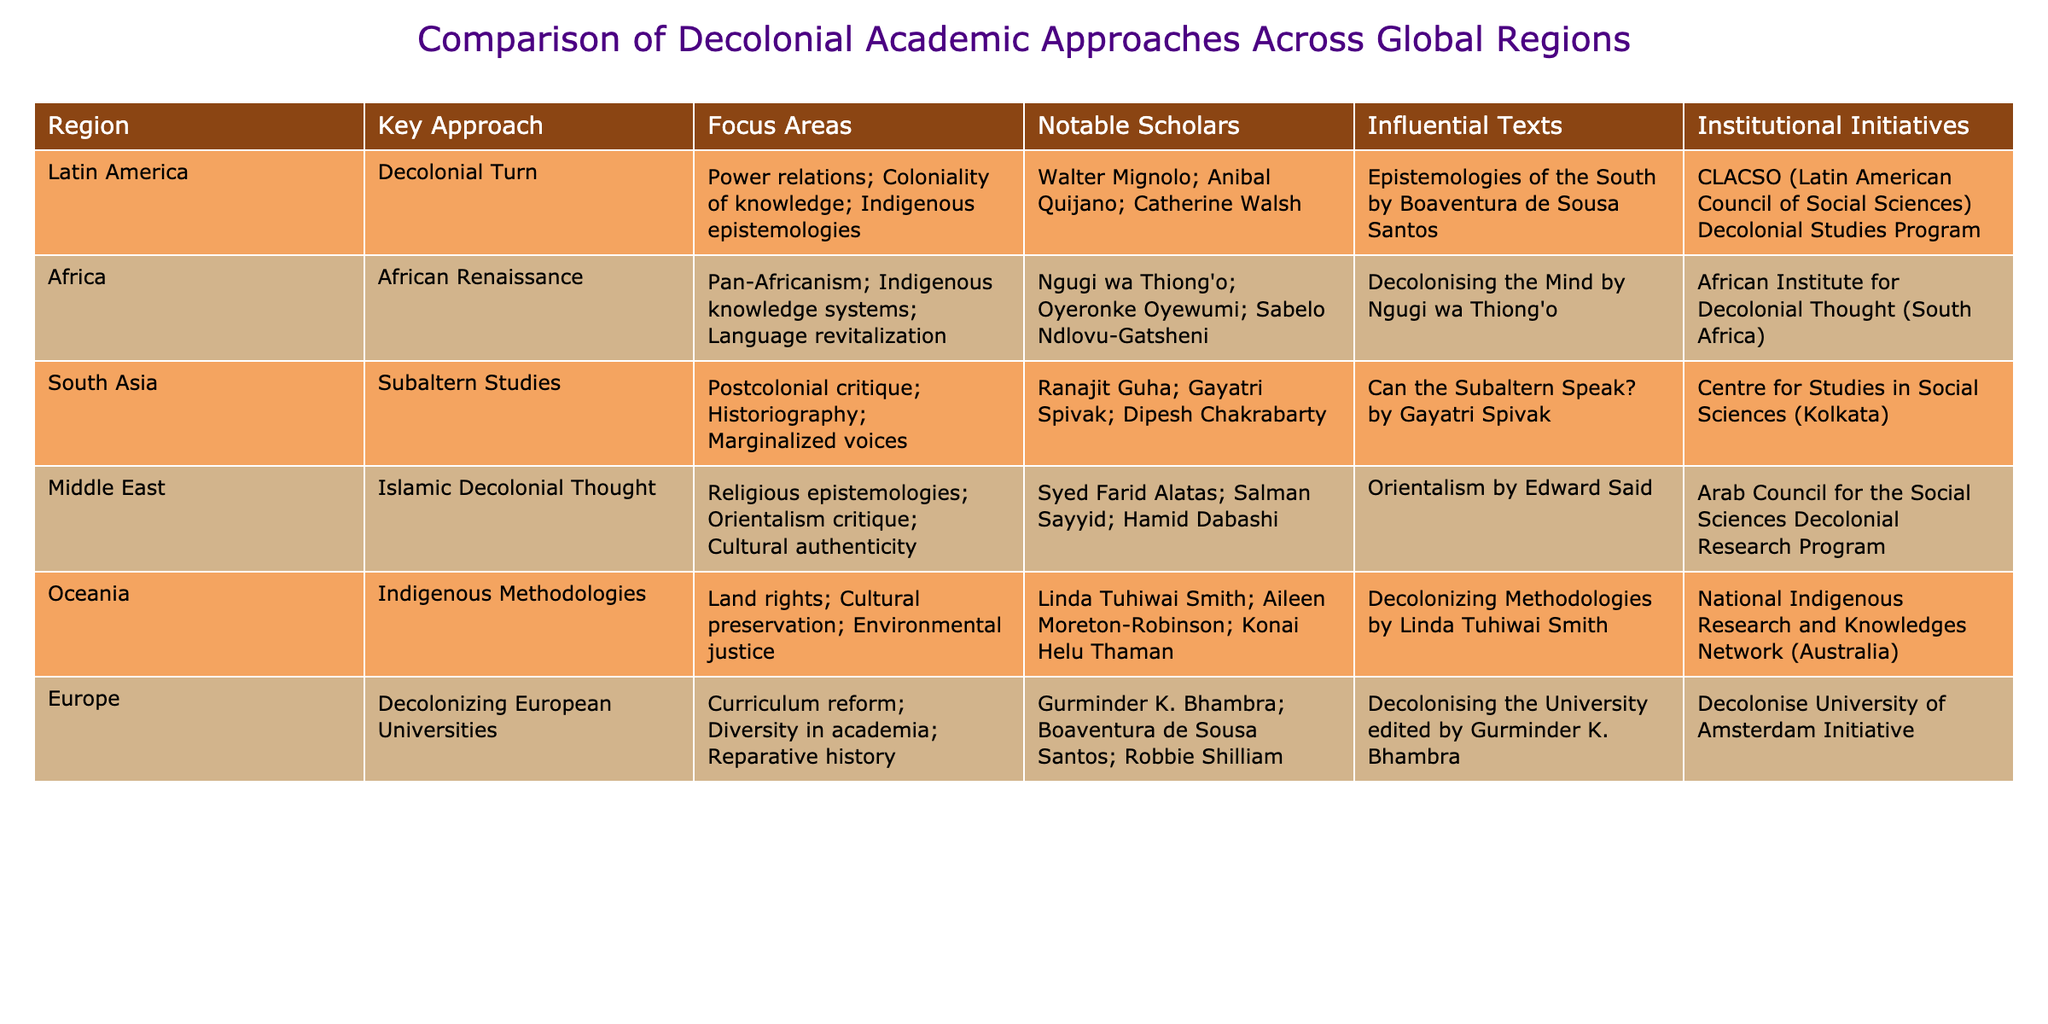What is the key approach used in Africa for decolonial studies? The table indicates that the key approach in Africa is the "African Renaissance." This can be directly retrieved from the "Key Approach" column for the Africa region.
Answer: African Renaissance Who is a notable scholar associated with Indigenous Methodologies in Oceania? According to the table, Linda Tuhiwai Smith is a notable scholar linked to the Indigenous Methodologies in Oceania, as listed in the "Notable Scholars" column for that region.
Answer: Linda Tuhiwai Smith How many influential texts are listed for the Latin America region? From the table, there is one influential text mentioned for Latin America, which is "Epistemologies of the South." It can be directly found in the "Influential Texts" column for the corresponding row.
Answer: One True or False: The Middle East focuses on language revitalization as part of its decolonial approach. The table lists the focus areas for the Middle East as "Religious epistemologies; Orientalism critique; Cultural authenticity," which does not include language revitalization mentioned for Africa. Therefore, the statement is false.
Answer: False What is the average number of key approaches mentioned across all regions? The table lists 6 regions, each with one key approach. To find the average, we sum the number of key approaches (6) and divide it by the number of regions (6), resulting in an average of 1.
Answer: 1 Which region has the focus area that emphasizes power relations and Indigenous epistemologies? The focus areas of the Latin America region include "Power relations; Coloniality of knowledge; Indigenous epistemologies," which can be directly identified from the "Focus Areas" column.
Answer: Latin America Are there any institutional initiatives listed for the South Asia region? The table does not mention any institutional initiatives specifically for South Asia, which can be verified by checking the "Institutional Initiatives" column for that region.
Answer: No Which scholarly approach in Europe emphasizes curriculum reform? The table indicates that the approach used in Europe is "Decolonizing European Universities," which emphasizes curriculum reform, as detailed in the "Key Approach" and "Focus Areas" columns for that row.
Answer: Decolonizing European Universities What is the commonality between influential texts from both Africa and Oceania? When analyzing the influential texts listed, both Africa and Oceania mention works that emphasize decolonization approaches within their respective cultural contexts—Africa has "Decolonising the Mind" while Oceania refers to "Decolonizing Methodologies." Both texts advocate for decolonization through indigenous and cultural lenses, highlighting a shared theme of re-evaluating knowledge systems.
Answer: They both focus on decolonization perspectives 